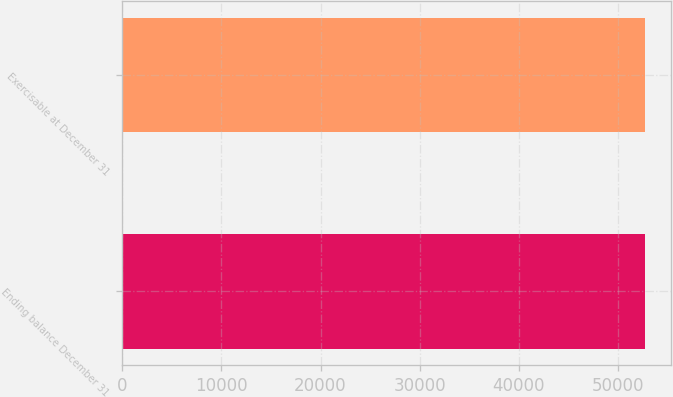<chart> <loc_0><loc_0><loc_500><loc_500><bar_chart><fcel>Ending balance December 31<fcel>Exercisable at December 31<nl><fcel>52689<fcel>52689.1<nl></chart> 